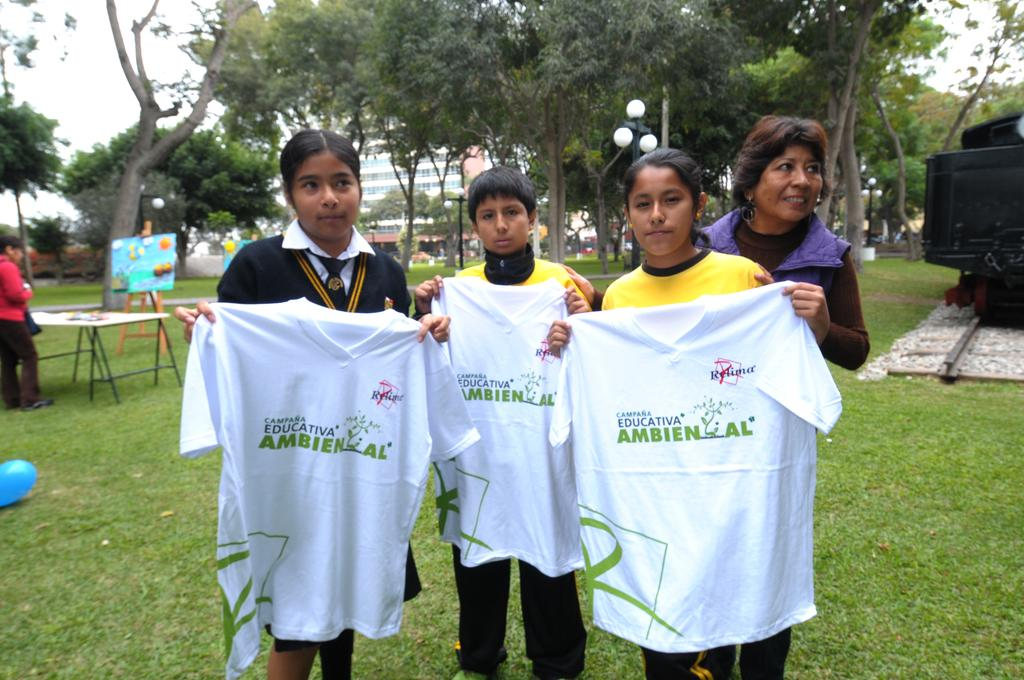What are the four people in the image doing? The four people are standing and holding t-shirts. What type of surface is visible beneath the people? There is grass visible in the image. What mode of transportation can be seen in the image? There is a train on a track in the image. Can you describe the background of the image? In the background, there is a person, a board with a stand, a table, trees, a building, and the sky. What is the opinion of the pear on the table in the image? There is no pear present in the image, so it is not possible to determine its opinion. 